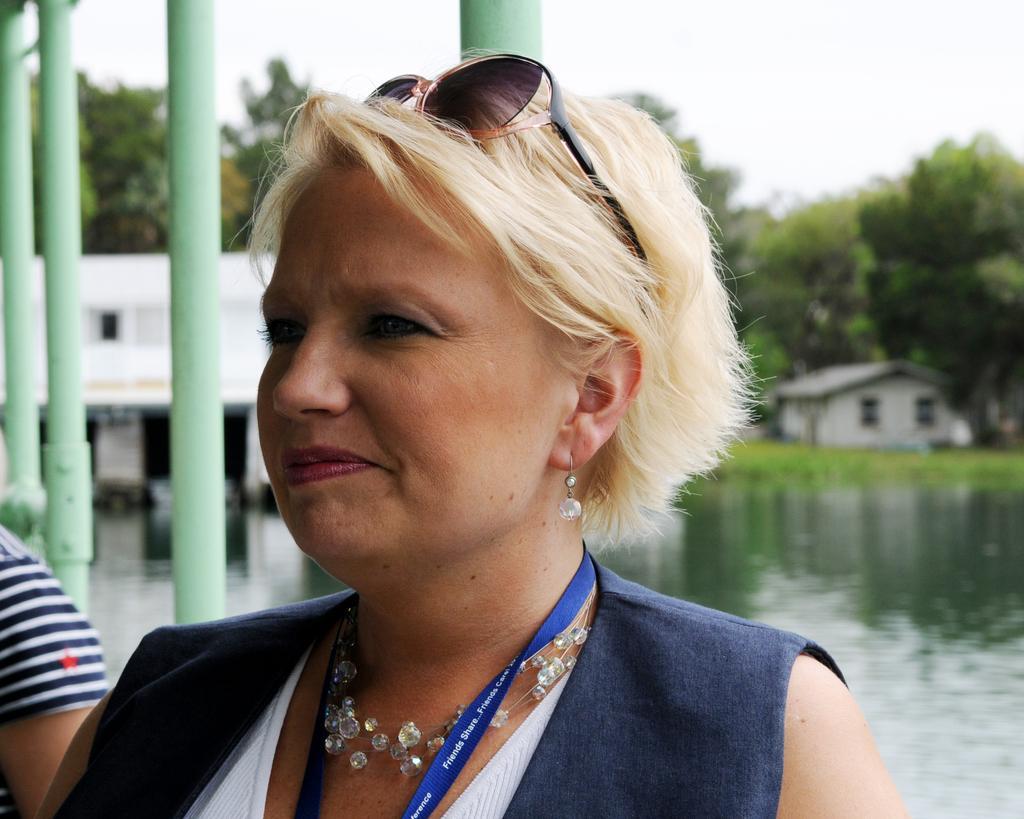Could you give a brief overview of what you see in this image? This image consists of a woman wearing a blue dress and a tag. In the background, there is water. And it looks like she is in the boat. On the left, there is another person. In the background, there are trees and houses. At the top, there is sky. 